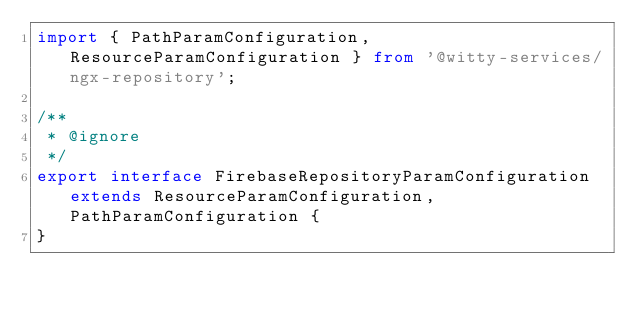Convert code to text. <code><loc_0><loc_0><loc_500><loc_500><_TypeScript_>import { PathParamConfiguration, ResourceParamConfiguration } from '@witty-services/ngx-repository';

/**
 * @ignore
 */
export interface FirebaseRepositoryParamConfiguration extends ResourceParamConfiguration, PathParamConfiguration {
}
</code> 